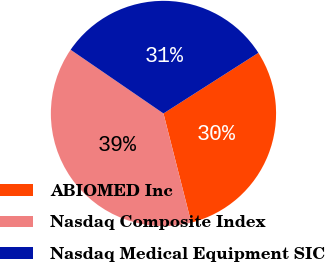Convert chart. <chart><loc_0><loc_0><loc_500><loc_500><pie_chart><fcel>ABIOMED Inc<fcel>Nasdaq Composite Index<fcel>Nasdaq Medical Equipment SIC<nl><fcel>30.08%<fcel>38.54%<fcel>31.38%<nl></chart> 